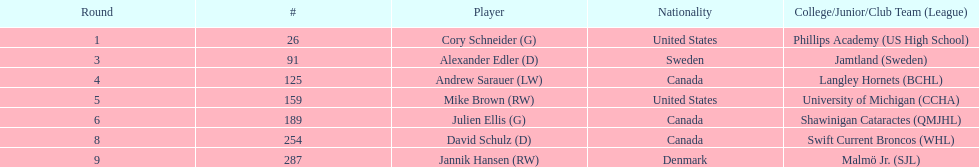Among players, who is the one and only person with denmark as their nationality? Jannik Hansen (RW). 